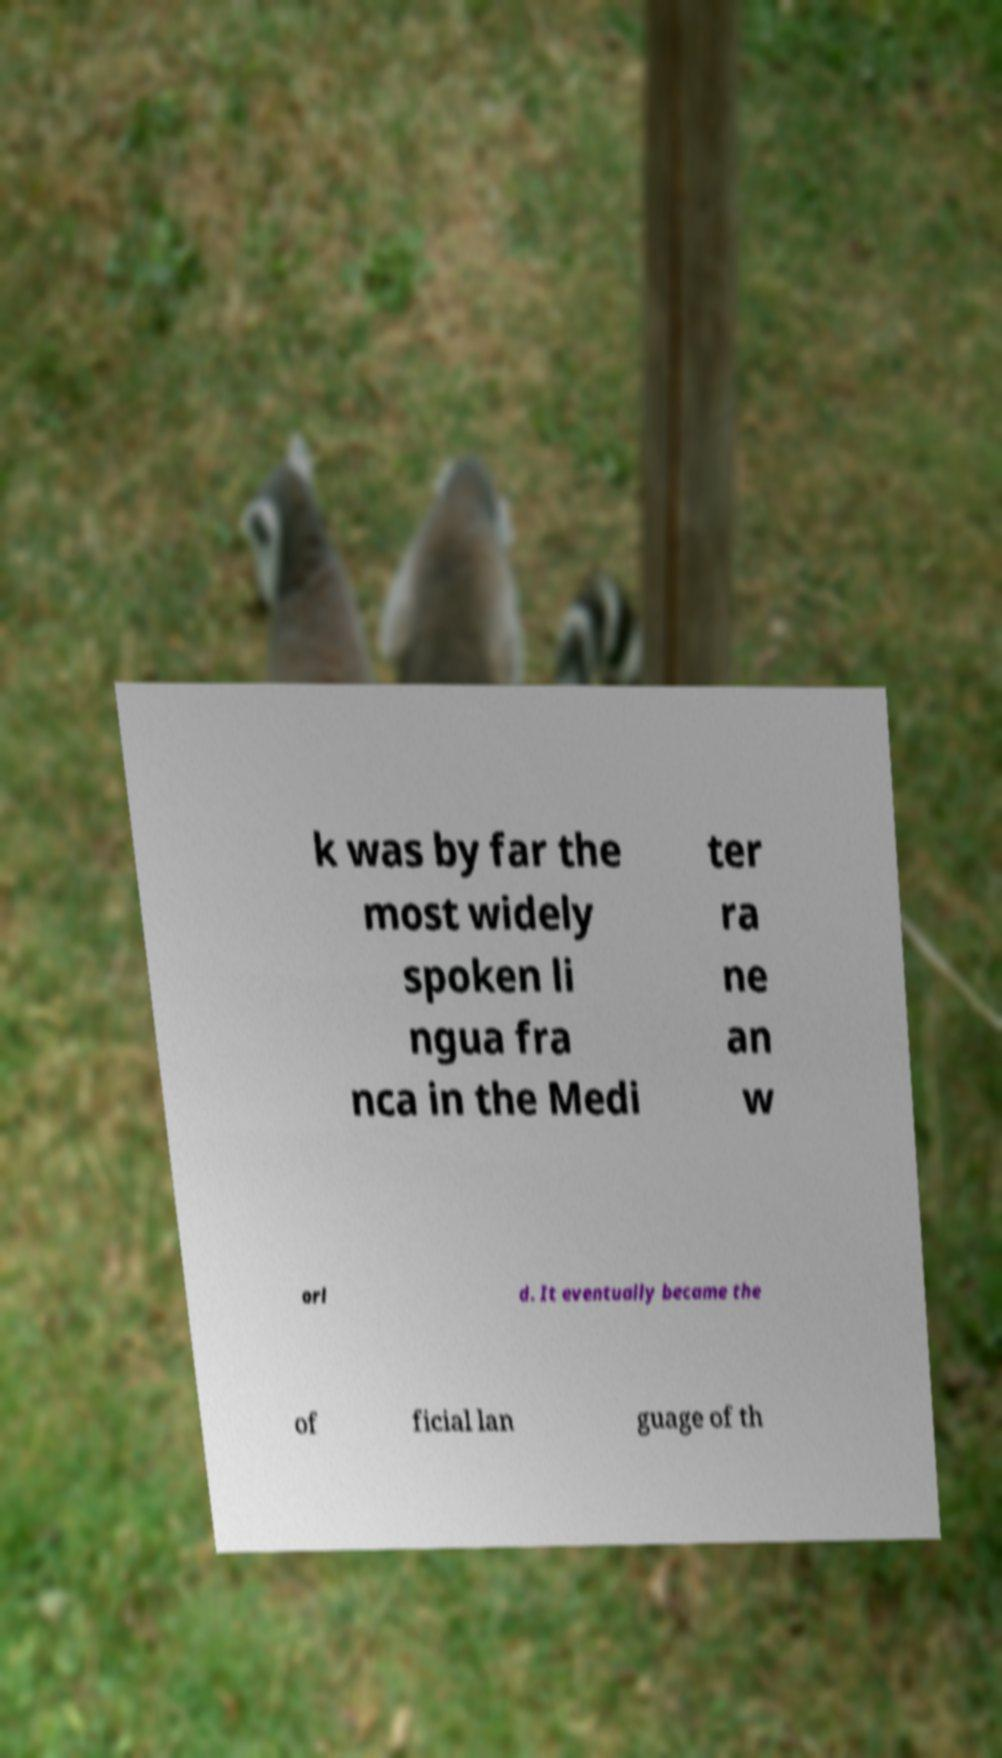For documentation purposes, I need the text within this image transcribed. Could you provide that? k was by far the most widely spoken li ngua fra nca in the Medi ter ra ne an w orl d. It eventually became the of ficial lan guage of th 